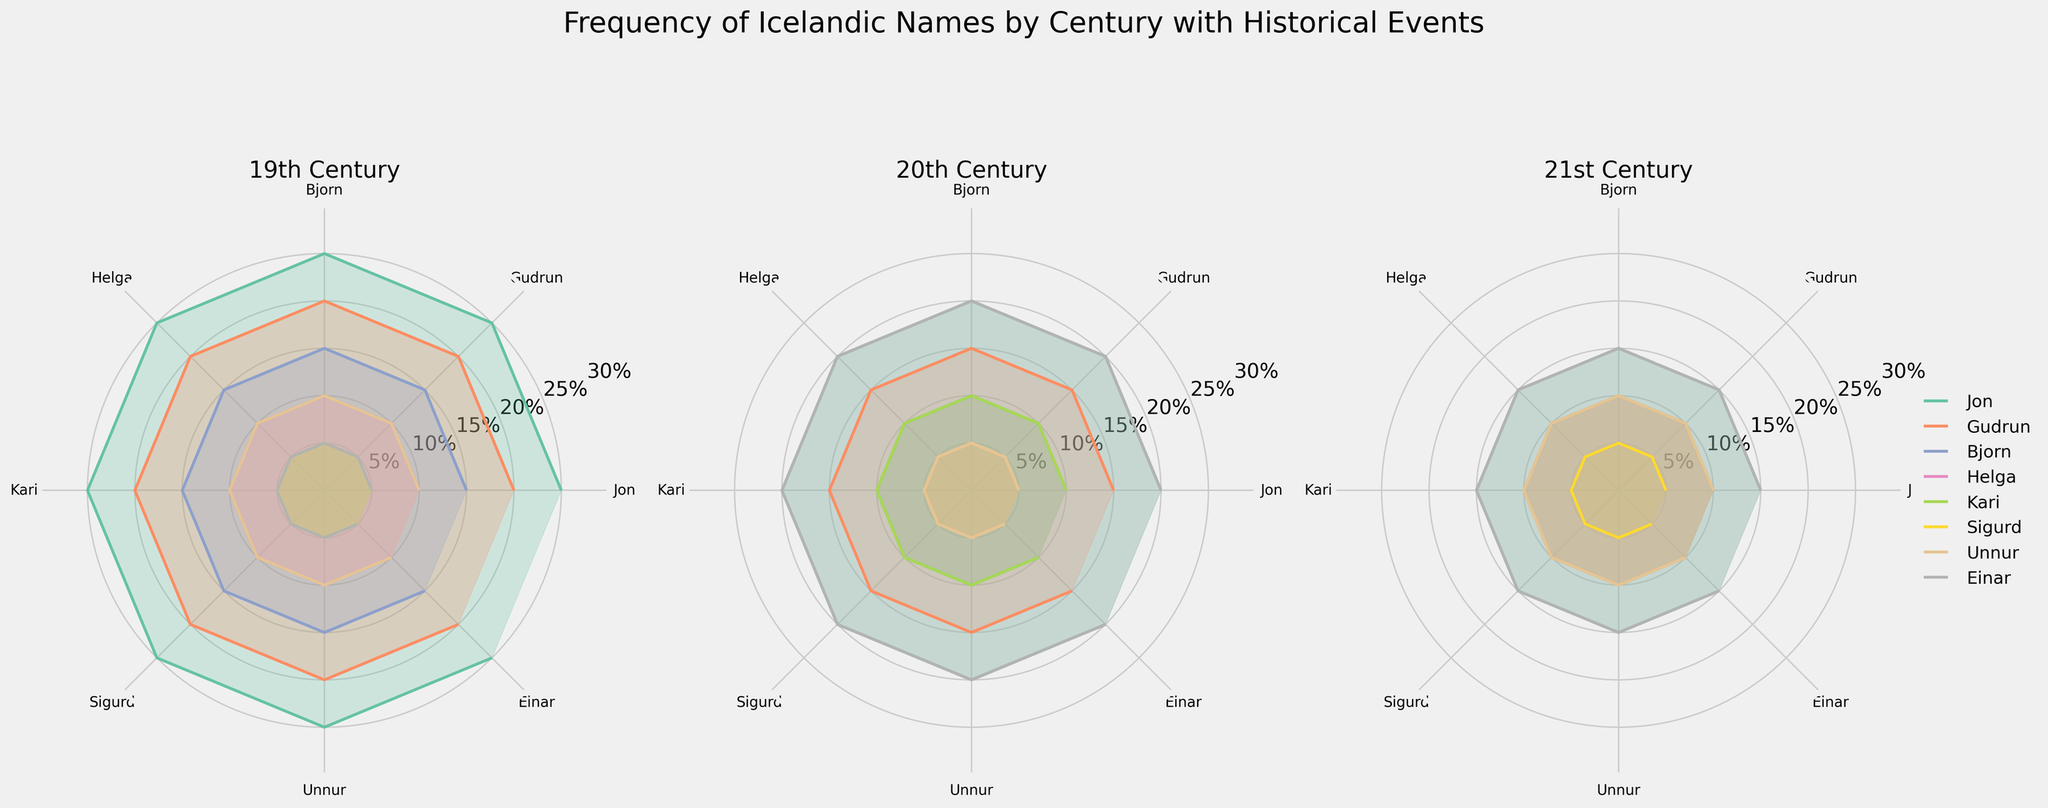What is the title of the figure? The title is located at the top of the figure and reads "Frequency of Icelandic Names by Century with Historical Events."
Answer: Frequency of Icelandic Names by Century with Historical Events Which century has the highest frequency of the name Jon? Looking at all three subplots for each century, we observe that Jon has a high frequency in the 19th century (0.25), 20th century (0.20), and 21st century (0.15). The highest frequency is in the 19th century.
Answer: 19th century Which name maintained its frequency percentage from the 19th to the 20th century? By comparing the frequency of each name in the 19th and 20th centuries, we see that Sigurd has a frequency of 0.05 in both centuries.
Answer: Sigurd What are the events associated with the 21st century? In the subplot for the 21st century, there are annotations indicating events. These events include the Financial Crisis of 2008, Climate Change Awareness in Iceland, Iceland National Football Team in FIFA World Cup, LGBTQ+ Rights Expansion, Renewable Energy Development, Tourism Boom in Iceland, Female Presidential Leadership, and Digital Innovation and Startups.
Answer: Financial Crisis of 2008, Climate Change Awareness in Iceland, Iceland National Football Team in FIFA World Cup, LGBTQ+ Rights Expansion, Renewable Energy Development, Tourism Boom in Iceland, Female Presidential Leadership, Digital Innovation and Startups How does the frequency of the name Helga in the 21st century compare to its frequency in the 20th century? The frequency of Helga in the 20th century is 0.05, while in the 21st century, it rises to 0.10. Therefore, Helga's frequency has increased from the 20th to the 21st century.
Answer: Increased What is the range of frequency percentages displayed on the radial axis? The radial axis has tick marks indicating percentages from 0% to 30%, marked at intervals of 5% (0.05).
Answer: 0% to 30% Which name shows the most stability in frequency across all three centuries? Evaluating the frequency for all names across the 19th, 20th, and 21st centuries, Gudrun shows a moderate consistency with frequencies of 0.20 (19th), 0.15 (20th), and 0.10 (21st). However, the most stable name is Sigurd, maintaining 0.05 across all three centuries.
Answer: Sigurd 